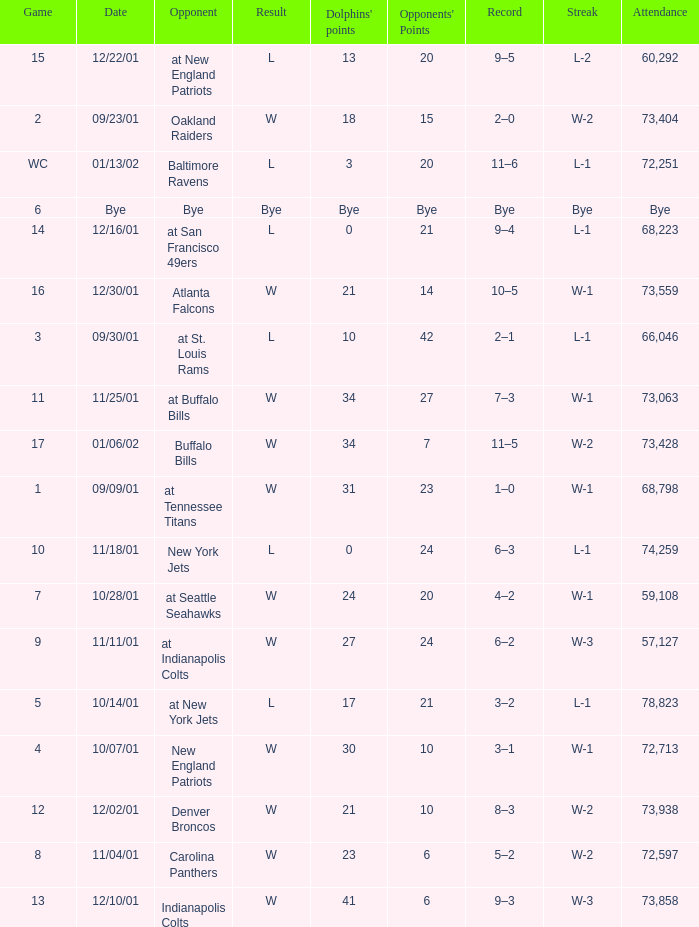What is the streak for game 2? W-2. 